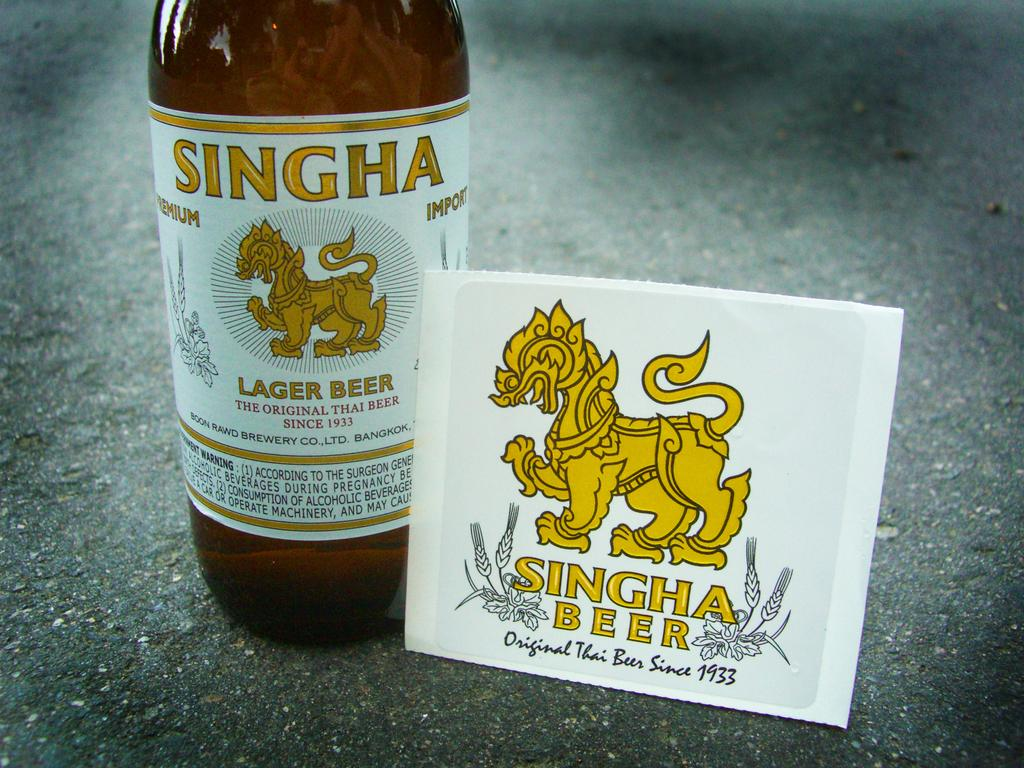<image>
Relay a brief, clear account of the picture shown. The Singha Beer label has a lion on top of the name 